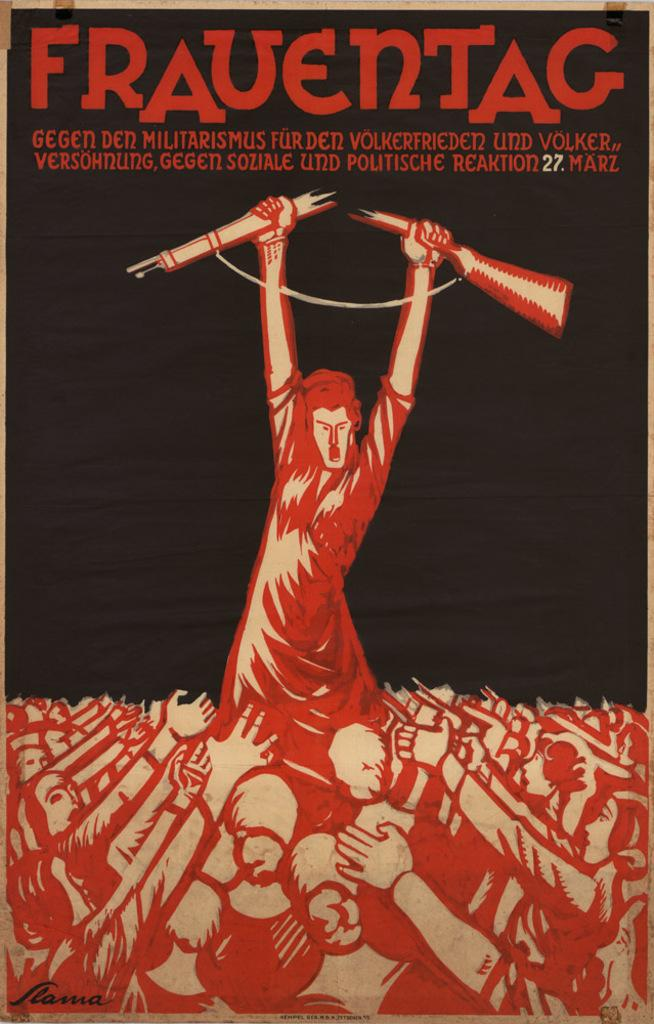Provide a one-sentence caption for the provided image. A man with two utensils in his hand entitled Frauentac. 